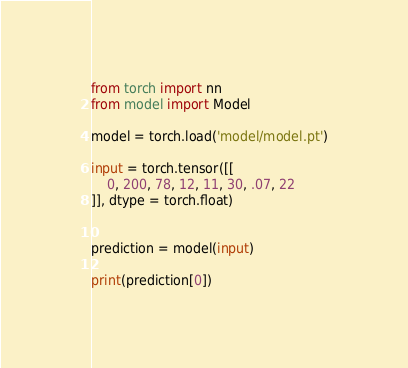Convert code to text. <code><loc_0><loc_0><loc_500><loc_500><_Python_>from torch import nn
from model import Model

model = torch.load('model/model.pt')

input = torch.tensor([[
    0, 200, 78, 12, 11, 30, .07, 22
]], dtype = torch.float)


prediction = model(input)
 
print(prediction[0])</code> 